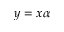Convert formula to latex. <formula><loc_0><loc_0><loc_500><loc_500>y = x \alpha</formula> 